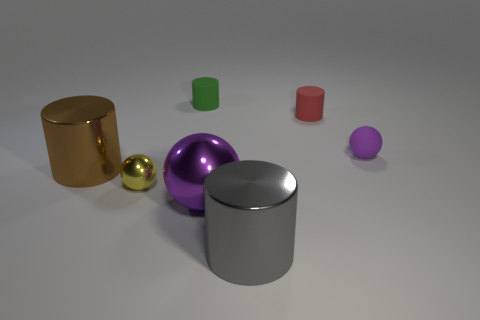There is a green rubber object; what number of big brown cylinders are on the right side of it?
Your answer should be very brief. 0. Are there more big metallic spheres right of the tiny red matte object than small matte things?
Provide a short and direct response. No. There is a yellow object that is made of the same material as the brown cylinder; what shape is it?
Make the answer very short. Sphere. The small sphere in front of the tiny ball to the right of the red matte cylinder is what color?
Provide a short and direct response. Yellow. Does the purple matte object have the same shape as the tiny green matte object?
Offer a very short reply. No. There is another small thing that is the same shape as the red object; what material is it?
Your response must be concise. Rubber. There is a big cylinder that is in front of the big metallic cylinder that is to the left of the small green cylinder; is there a red cylinder that is in front of it?
Your answer should be compact. No. Do the yellow metallic object and the purple object to the left of the small purple thing have the same shape?
Provide a short and direct response. Yes. Are there any other things that are the same color as the small matte sphere?
Your answer should be compact. Yes. Is the color of the small ball that is in front of the brown metal cylinder the same as the small rubber thing to the left of the tiny red cylinder?
Give a very brief answer. No. 